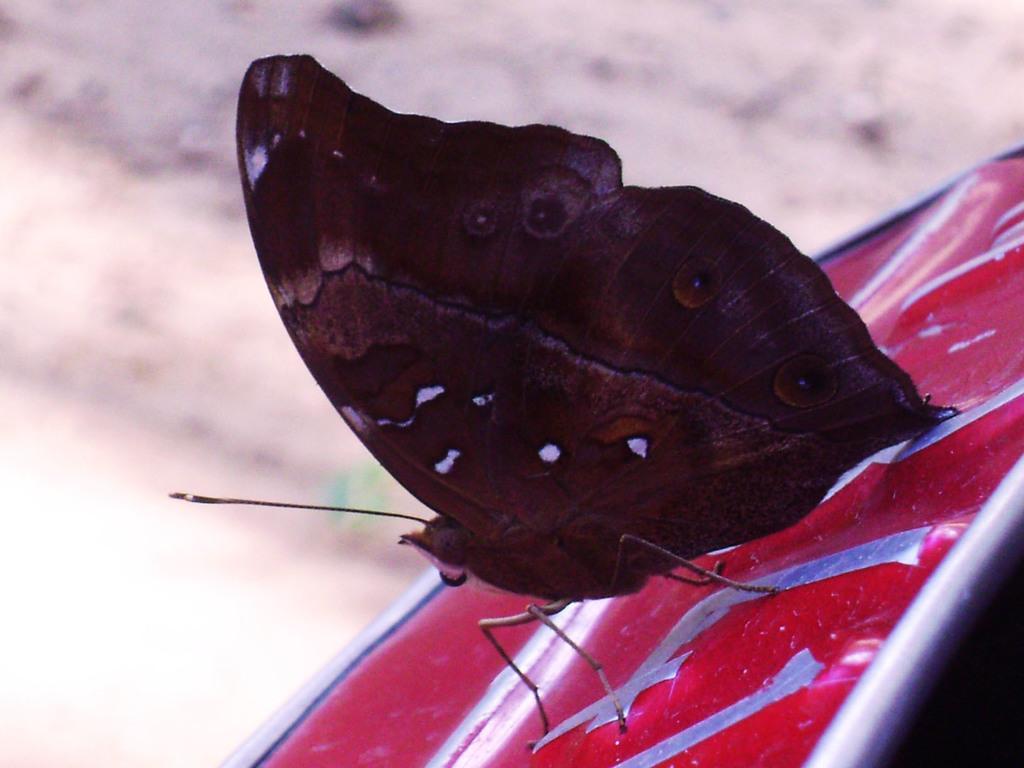Could you give a brief overview of what you see in this image? In this image I can see a butterfly visible on the red color stand. 